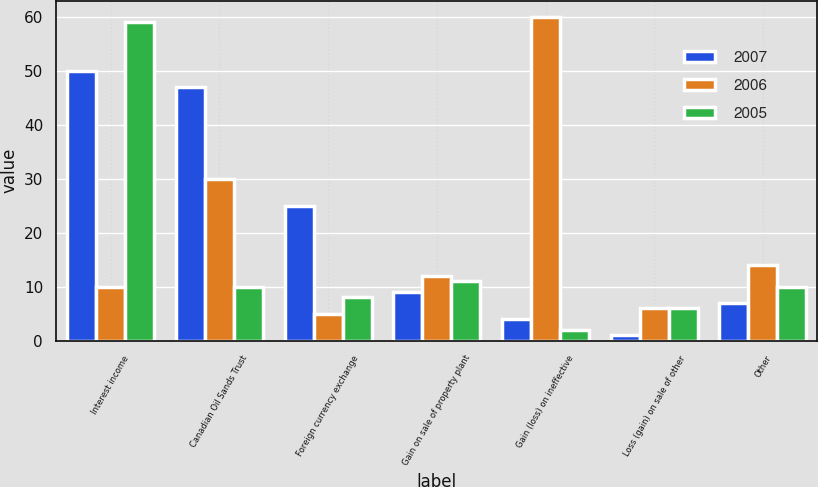<chart> <loc_0><loc_0><loc_500><loc_500><stacked_bar_chart><ecel><fcel>Interest income<fcel>Canadian Oil Sands Trust<fcel>Foreign currency exchange<fcel>Gain on sale of property plant<fcel>Gain (loss) on ineffective<fcel>Loss (gain) on sale of other<fcel>Other<nl><fcel>2007<fcel>50<fcel>47<fcel>25<fcel>9<fcel>4<fcel>1<fcel>7<nl><fcel>2006<fcel>10<fcel>30<fcel>5<fcel>12<fcel>60<fcel>6<fcel>14<nl><fcel>2005<fcel>59<fcel>10<fcel>8<fcel>11<fcel>2<fcel>6<fcel>10<nl></chart> 